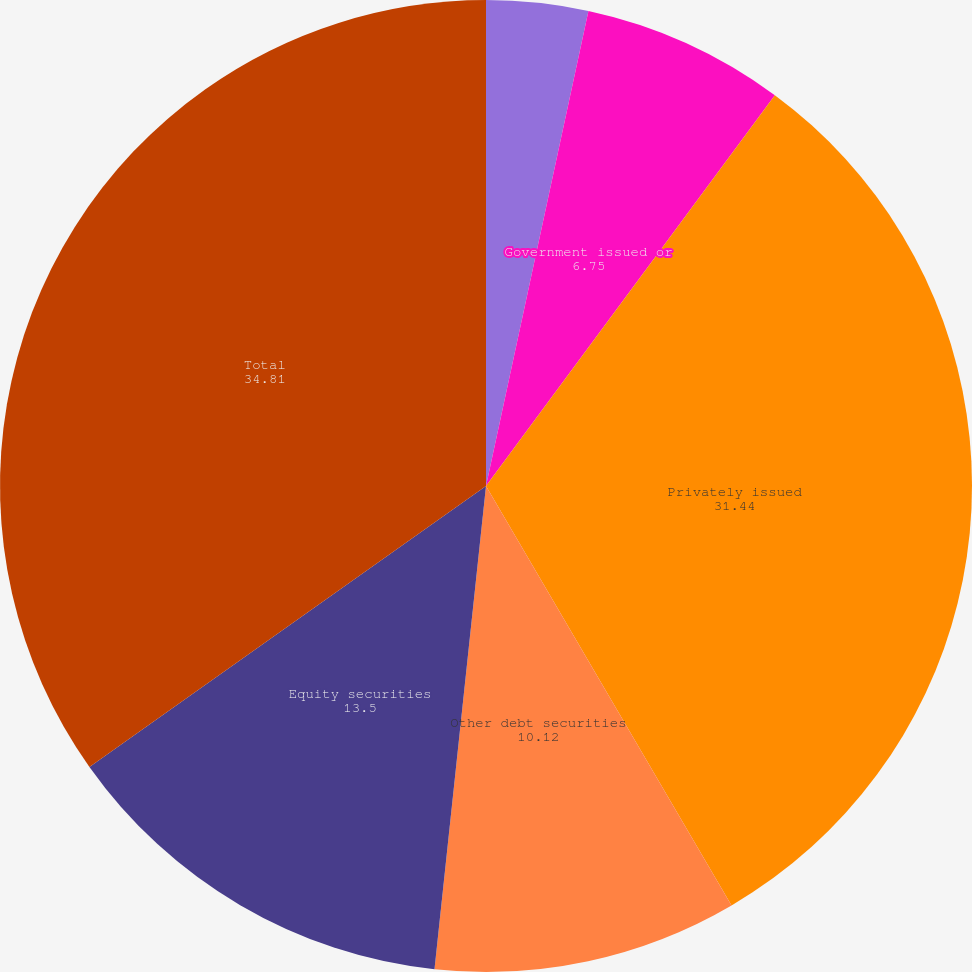Convert chart to OTSL. <chart><loc_0><loc_0><loc_500><loc_500><pie_chart><fcel>Obligations of states and<fcel>Government issued or<fcel>Privately issued<fcel>Other debt securities<fcel>Equity securities<fcel>Total<fcel>US Treasury and federal<nl><fcel>3.38%<fcel>6.75%<fcel>31.44%<fcel>10.12%<fcel>13.5%<fcel>34.81%<fcel>0.0%<nl></chart> 